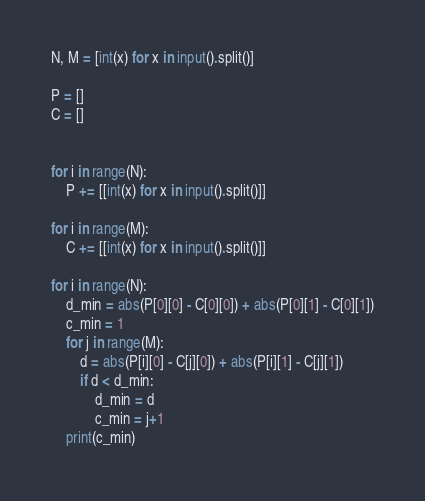Convert code to text. <code><loc_0><loc_0><loc_500><loc_500><_Python_>N, M = [int(x) for x in input().split()]

P = []
C = []


for i in range(N):
    P += [[int(x) for x in input().split()]]
    
for i in range(M):
    C += [[int(x) for x in input().split()]]

for i in range(N):
    d_min = abs(P[0][0] - C[0][0]) + abs(P[0][1] - C[0][1])
    c_min = 1
    for j in range(M):
        d = abs(P[i][0] - C[j][0]) + abs(P[i][1] - C[j][1])
        if d < d_min:
            d_min = d
            c_min = j+1
    print(c_min)</code> 